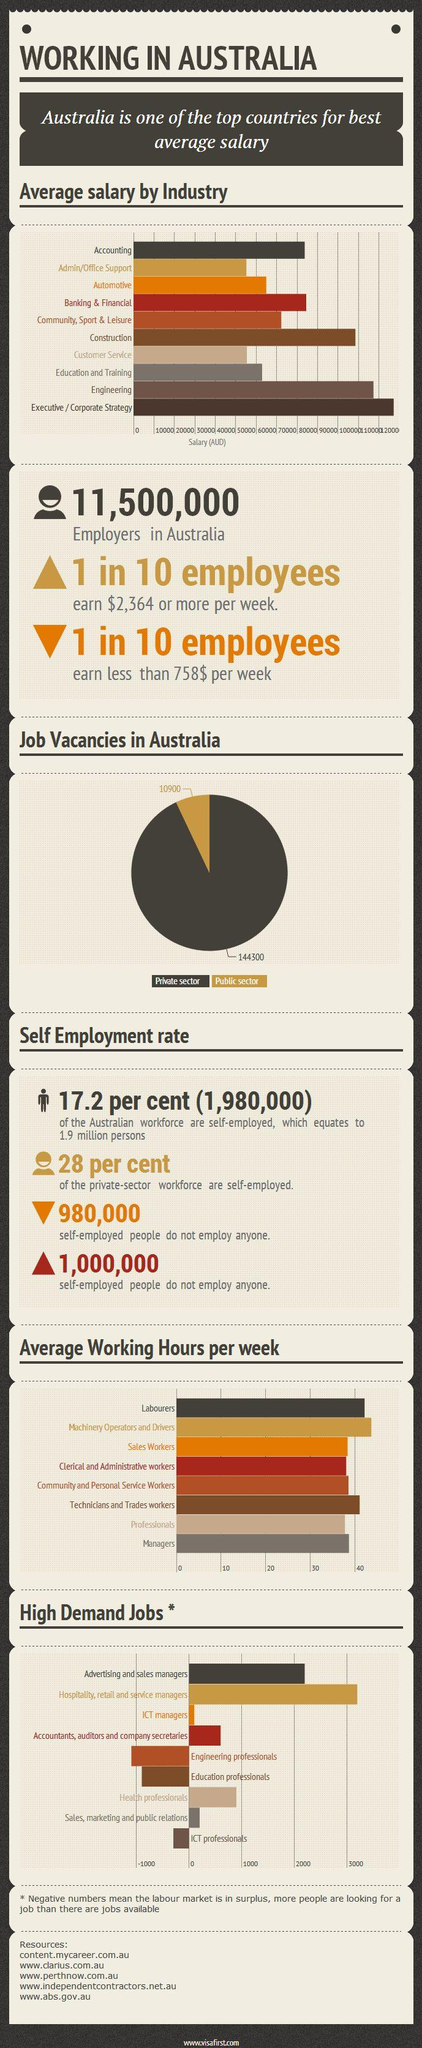Indicate a few pertinent items in this graphic. There are currently 10,900 job vacancies available in the private sector in Australia. Engineering is the second highest paying industry in Australia, followed by Medicine. According to a recent survey, construction is the third highest paying industry in Australia, offering competitive salaries to those in the field. There are approximately 144,300 job vacancies available in the public sector in Australia. Hospitality, retail, and service management positions are the most sought after jobs in Australia, as demonstrated by their high demand and popularity among job seekers and employers alike. 